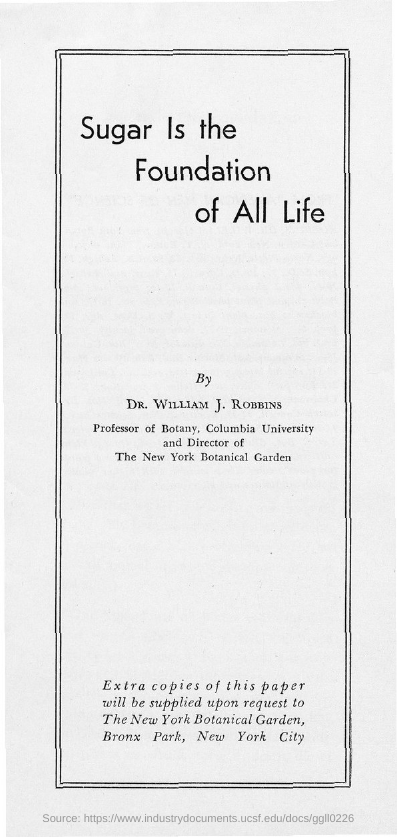What is the title of the document?
Your answer should be compact. Sugar is the foundation of all life. 